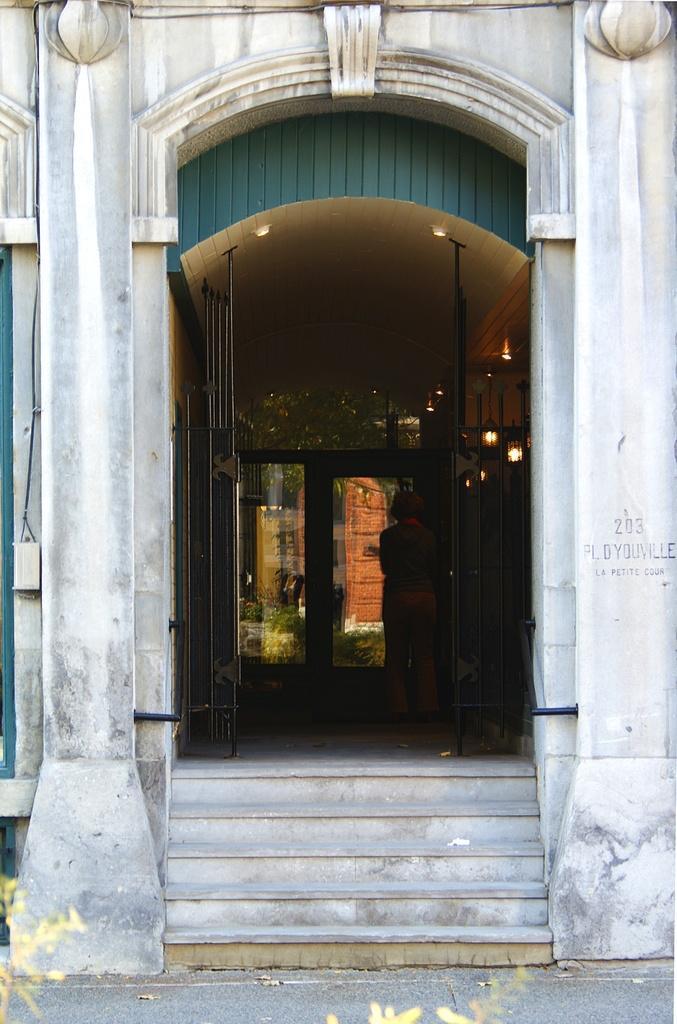Could you give a brief overview of what you see in this image? In the image there is an entrance image of some building, there are stairs and there is a door in front of the stairs, the doors are open and in front of the doors there is a woman and behind her there are doors closed. 